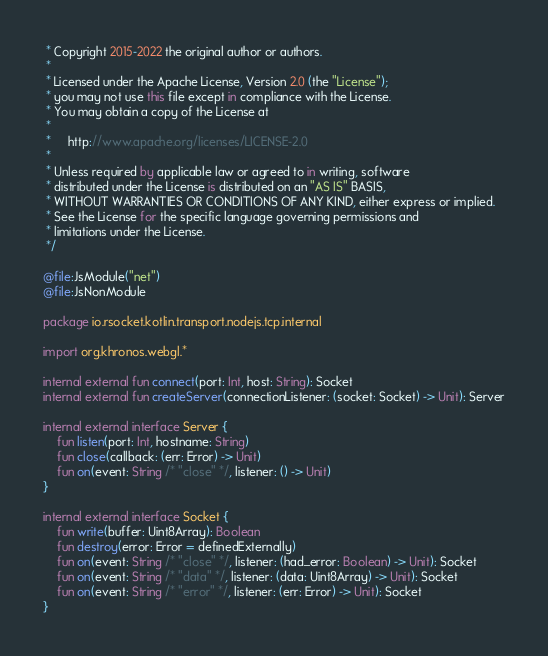Convert code to text. <code><loc_0><loc_0><loc_500><loc_500><_Kotlin_> * Copyright 2015-2022 the original author or authors.
 *
 * Licensed under the Apache License, Version 2.0 (the "License");
 * you may not use this file except in compliance with the License.
 * You may obtain a copy of the License at
 *
 *     http://www.apache.org/licenses/LICENSE-2.0
 *
 * Unless required by applicable law or agreed to in writing, software
 * distributed under the License is distributed on an "AS IS" BASIS,
 * WITHOUT WARRANTIES OR CONDITIONS OF ANY KIND, either express or implied.
 * See the License for the specific language governing permissions and
 * limitations under the License.
 */

@file:JsModule("net")
@file:JsNonModule

package io.rsocket.kotlin.transport.nodejs.tcp.internal

import org.khronos.webgl.*

internal external fun connect(port: Int, host: String): Socket
internal external fun createServer(connectionListener: (socket: Socket) -> Unit): Server

internal external interface Server {
    fun listen(port: Int, hostname: String)
    fun close(callback: (err: Error) -> Unit)
    fun on(event: String /* "close" */, listener: () -> Unit)
}

internal external interface Socket {
    fun write(buffer: Uint8Array): Boolean
    fun destroy(error: Error = definedExternally)
    fun on(event: String /* "close" */, listener: (had_error: Boolean) -> Unit): Socket
    fun on(event: String /* "data" */, listener: (data: Uint8Array) -> Unit): Socket
    fun on(event: String /* "error" */, listener: (err: Error) -> Unit): Socket
}
</code> 